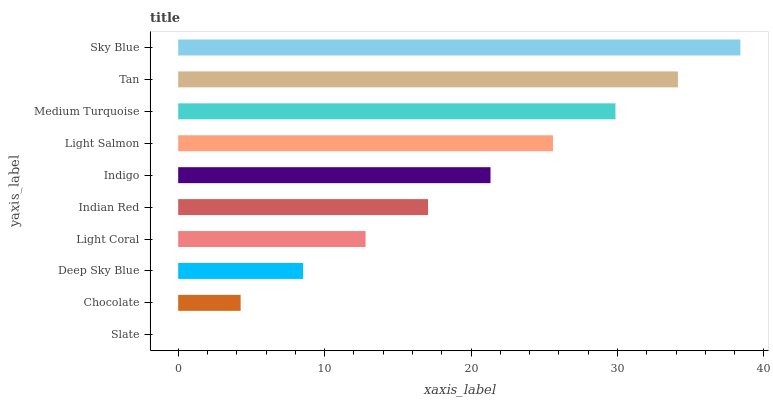Is Slate the minimum?
Answer yes or no. Yes. Is Sky Blue the maximum?
Answer yes or no. Yes. Is Chocolate the minimum?
Answer yes or no. No. Is Chocolate the maximum?
Answer yes or no. No. Is Chocolate greater than Slate?
Answer yes or no. Yes. Is Slate less than Chocolate?
Answer yes or no. Yes. Is Slate greater than Chocolate?
Answer yes or no. No. Is Chocolate less than Slate?
Answer yes or no. No. Is Indigo the high median?
Answer yes or no. Yes. Is Indian Red the low median?
Answer yes or no. Yes. Is Indian Red the high median?
Answer yes or no. No. Is Sky Blue the low median?
Answer yes or no. No. 